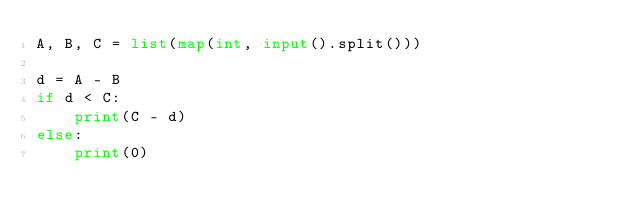Convert code to text. <code><loc_0><loc_0><loc_500><loc_500><_Python_>A, B, C = list(map(int, input().split()))

d = A - B
if d < C:
    print(C - d)
else:
    print(0)</code> 